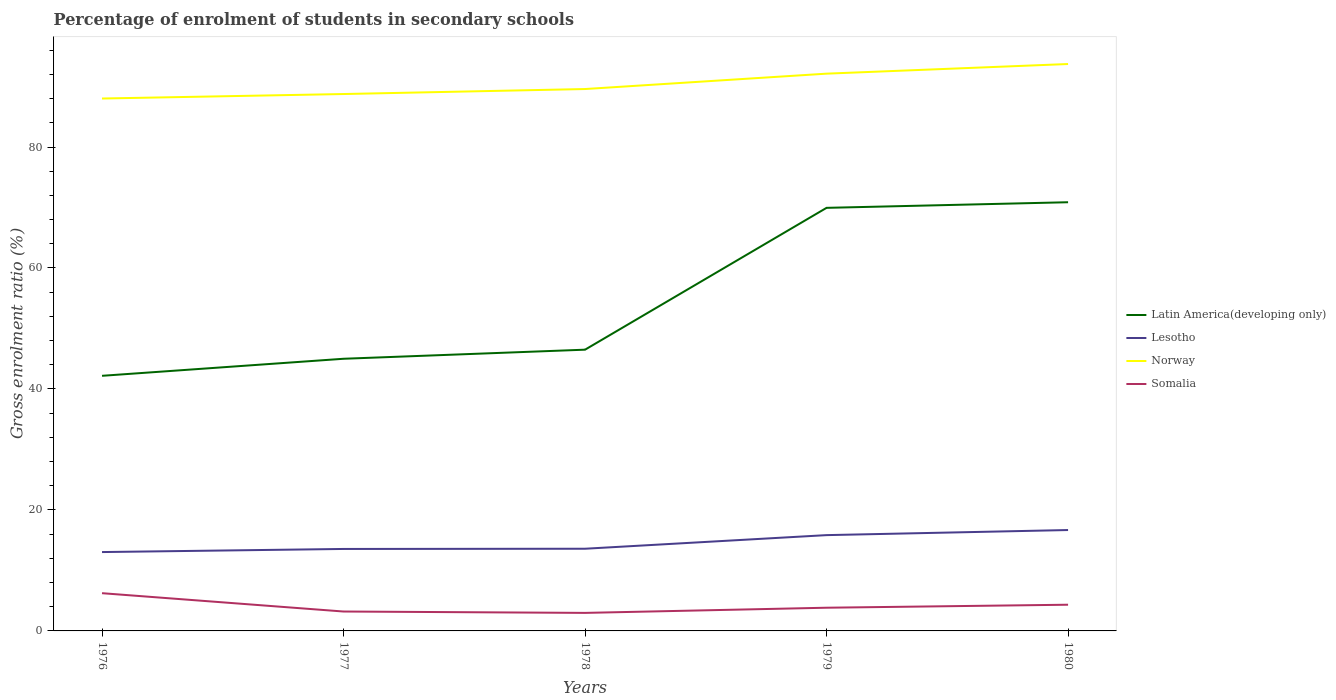Does the line corresponding to Somalia intersect with the line corresponding to Lesotho?
Offer a very short reply. No. Across all years, what is the maximum percentage of students enrolled in secondary schools in Norway?
Provide a succinct answer. 88.02. In which year was the percentage of students enrolled in secondary schools in Lesotho maximum?
Give a very brief answer. 1976. What is the total percentage of students enrolled in secondary schools in Lesotho in the graph?
Provide a succinct answer. -0.51. What is the difference between the highest and the second highest percentage of students enrolled in secondary schools in Somalia?
Your response must be concise. 3.26. What is the difference between the highest and the lowest percentage of students enrolled in secondary schools in Latin America(developing only)?
Offer a very short reply. 2. Are the values on the major ticks of Y-axis written in scientific E-notation?
Your answer should be very brief. No. Does the graph contain any zero values?
Keep it short and to the point. No. Does the graph contain grids?
Provide a short and direct response. No. What is the title of the graph?
Give a very brief answer. Percentage of enrolment of students in secondary schools. Does "Malta" appear as one of the legend labels in the graph?
Your answer should be compact. No. What is the label or title of the X-axis?
Provide a short and direct response. Years. What is the label or title of the Y-axis?
Your response must be concise. Gross enrolment ratio (%). What is the Gross enrolment ratio (%) in Latin America(developing only) in 1976?
Offer a very short reply. 42.18. What is the Gross enrolment ratio (%) in Lesotho in 1976?
Offer a very short reply. 13.04. What is the Gross enrolment ratio (%) of Norway in 1976?
Your response must be concise. 88.02. What is the Gross enrolment ratio (%) in Somalia in 1976?
Ensure brevity in your answer.  6.24. What is the Gross enrolment ratio (%) of Latin America(developing only) in 1977?
Keep it short and to the point. 44.99. What is the Gross enrolment ratio (%) of Lesotho in 1977?
Provide a succinct answer. 13.55. What is the Gross enrolment ratio (%) in Norway in 1977?
Keep it short and to the point. 88.76. What is the Gross enrolment ratio (%) of Somalia in 1977?
Make the answer very short. 3.21. What is the Gross enrolment ratio (%) of Latin America(developing only) in 1978?
Offer a very short reply. 46.5. What is the Gross enrolment ratio (%) of Lesotho in 1978?
Provide a succinct answer. 13.59. What is the Gross enrolment ratio (%) in Norway in 1978?
Your answer should be compact. 89.59. What is the Gross enrolment ratio (%) of Somalia in 1978?
Provide a short and direct response. 2.98. What is the Gross enrolment ratio (%) in Latin America(developing only) in 1979?
Make the answer very short. 69.94. What is the Gross enrolment ratio (%) of Lesotho in 1979?
Your answer should be compact. 15.84. What is the Gross enrolment ratio (%) in Norway in 1979?
Offer a very short reply. 92.13. What is the Gross enrolment ratio (%) in Somalia in 1979?
Make the answer very short. 3.84. What is the Gross enrolment ratio (%) of Latin America(developing only) in 1980?
Make the answer very short. 70.87. What is the Gross enrolment ratio (%) in Lesotho in 1980?
Your answer should be compact. 16.68. What is the Gross enrolment ratio (%) of Norway in 1980?
Keep it short and to the point. 93.72. What is the Gross enrolment ratio (%) in Somalia in 1980?
Your response must be concise. 4.33. Across all years, what is the maximum Gross enrolment ratio (%) in Latin America(developing only)?
Offer a terse response. 70.87. Across all years, what is the maximum Gross enrolment ratio (%) of Lesotho?
Your answer should be compact. 16.68. Across all years, what is the maximum Gross enrolment ratio (%) in Norway?
Offer a terse response. 93.72. Across all years, what is the maximum Gross enrolment ratio (%) in Somalia?
Offer a terse response. 6.24. Across all years, what is the minimum Gross enrolment ratio (%) of Latin America(developing only)?
Offer a very short reply. 42.18. Across all years, what is the minimum Gross enrolment ratio (%) in Lesotho?
Your answer should be very brief. 13.04. Across all years, what is the minimum Gross enrolment ratio (%) in Norway?
Your response must be concise. 88.02. Across all years, what is the minimum Gross enrolment ratio (%) in Somalia?
Offer a terse response. 2.98. What is the total Gross enrolment ratio (%) of Latin America(developing only) in the graph?
Your answer should be compact. 274.48. What is the total Gross enrolment ratio (%) in Lesotho in the graph?
Offer a very short reply. 72.69. What is the total Gross enrolment ratio (%) of Norway in the graph?
Keep it short and to the point. 452.22. What is the total Gross enrolment ratio (%) in Somalia in the graph?
Provide a short and direct response. 20.59. What is the difference between the Gross enrolment ratio (%) in Latin America(developing only) in 1976 and that in 1977?
Give a very brief answer. -2.82. What is the difference between the Gross enrolment ratio (%) of Lesotho in 1976 and that in 1977?
Your answer should be very brief. -0.51. What is the difference between the Gross enrolment ratio (%) of Norway in 1976 and that in 1977?
Your answer should be very brief. -0.74. What is the difference between the Gross enrolment ratio (%) in Somalia in 1976 and that in 1977?
Keep it short and to the point. 3.03. What is the difference between the Gross enrolment ratio (%) of Latin America(developing only) in 1976 and that in 1978?
Your answer should be very brief. -4.32. What is the difference between the Gross enrolment ratio (%) of Lesotho in 1976 and that in 1978?
Offer a terse response. -0.55. What is the difference between the Gross enrolment ratio (%) of Norway in 1976 and that in 1978?
Your answer should be very brief. -1.57. What is the difference between the Gross enrolment ratio (%) of Somalia in 1976 and that in 1978?
Offer a terse response. 3.26. What is the difference between the Gross enrolment ratio (%) in Latin America(developing only) in 1976 and that in 1979?
Offer a very short reply. -27.77. What is the difference between the Gross enrolment ratio (%) of Lesotho in 1976 and that in 1979?
Offer a very short reply. -2.8. What is the difference between the Gross enrolment ratio (%) in Norway in 1976 and that in 1979?
Keep it short and to the point. -4.11. What is the difference between the Gross enrolment ratio (%) in Somalia in 1976 and that in 1979?
Provide a succinct answer. 2.4. What is the difference between the Gross enrolment ratio (%) in Latin America(developing only) in 1976 and that in 1980?
Your response must be concise. -28.7. What is the difference between the Gross enrolment ratio (%) in Lesotho in 1976 and that in 1980?
Ensure brevity in your answer.  -3.64. What is the difference between the Gross enrolment ratio (%) in Norway in 1976 and that in 1980?
Offer a terse response. -5.7. What is the difference between the Gross enrolment ratio (%) in Somalia in 1976 and that in 1980?
Your answer should be compact. 1.91. What is the difference between the Gross enrolment ratio (%) of Latin America(developing only) in 1977 and that in 1978?
Offer a terse response. -1.5. What is the difference between the Gross enrolment ratio (%) of Lesotho in 1977 and that in 1978?
Your answer should be compact. -0.04. What is the difference between the Gross enrolment ratio (%) in Norway in 1977 and that in 1978?
Your response must be concise. -0.83. What is the difference between the Gross enrolment ratio (%) of Somalia in 1977 and that in 1978?
Give a very brief answer. 0.23. What is the difference between the Gross enrolment ratio (%) of Latin America(developing only) in 1977 and that in 1979?
Provide a short and direct response. -24.95. What is the difference between the Gross enrolment ratio (%) of Lesotho in 1977 and that in 1979?
Provide a succinct answer. -2.29. What is the difference between the Gross enrolment ratio (%) of Norway in 1977 and that in 1979?
Your answer should be very brief. -3.37. What is the difference between the Gross enrolment ratio (%) of Somalia in 1977 and that in 1979?
Your answer should be compact. -0.63. What is the difference between the Gross enrolment ratio (%) of Latin America(developing only) in 1977 and that in 1980?
Provide a succinct answer. -25.88. What is the difference between the Gross enrolment ratio (%) of Lesotho in 1977 and that in 1980?
Keep it short and to the point. -3.13. What is the difference between the Gross enrolment ratio (%) of Norway in 1977 and that in 1980?
Give a very brief answer. -4.96. What is the difference between the Gross enrolment ratio (%) in Somalia in 1977 and that in 1980?
Keep it short and to the point. -1.12. What is the difference between the Gross enrolment ratio (%) of Latin America(developing only) in 1978 and that in 1979?
Ensure brevity in your answer.  -23.45. What is the difference between the Gross enrolment ratio (%) in Lesotho in 1978 and that in 1979?
Your response must be concise. -2.25. What is the difference between the Gross enrolment ratio (%) of Norway in 1978 and that in 1979?
Provide a short and direct response. -2.54. What is the difference between the Gross enrolment ratio (%) in Somalia in 1978 and that in 1979?
Make the answer very short. -0.85. What is the difference between the Gross enrolment ratio (%) of Latin America(developing only) in 1978 and that in 1980?
Give a very brief answer. -24.38. What is the difference between the Gross enrolment ratio (%) of Lesotho in 1978 and that in 1980?
Provide a succinct answer. -3.09. What is the difference between the Gross enrolment ratio (%) in Norway in 1978 and that in 1980?
Provide a succinct answer. -4.14. What is the difference between the Gross enrolment ratio (%) in Somalia in 1978 and that in 1980?
Offer a very short reply. -1.35. What is the difference between the Gross enrolment ratio (%) of Latin America(developing only) in 1979 and that in 1980?
Offer a terse response. -0.93. What is the difference between the Gross enrolment ratio (%) in Lesotho in 1979 and that in 1980?
Offer a terse response. -0.84. What is the difference between the Gross enrolment ratio (%) in Norway in 1979 and that in 1980?
Provide a succinct answer. -1.59. What is the difference between the Gross enrolment ratio (%) of Somalia in 1979 and that in 1980?
Your answer should be compact. -0.5. What is the difference between the Gross enrolment ratio (%) of Latin America(developing only) in 1976 and the Gross enrolment ratio (%) of Lesotho in 1977?
Your response must be concise. 28.63. What is the difference between the Gross enrolment ratio (%) of Latin America(developing only) in 1976 and the Gross enrolment ratio (%) of Norway in 1977?
Offer a terse response. -46.59. What is the difference between the Gross enrolment ratio (%) of Latin America(developing only) in 1976 and the Gross enrolment ratio (%) of Somalia in 1977?
Make the answer very short. 38.97. What is the difference between the Gross enrolment ratio (%) in Lesotho in 1976 and the Gross enrolment ratio (%) in Norway in 1977?
Your response must be concise. -75.72. What is the difference between the Gross enrolment ratio (%) of Lesotho in 1976 and the Gross enrolment ratio (%) of Somalia in 1977?
Give a very brief answer. 9.83. What is the difference between the Gross enrolment ratio (%) of Norway in 1976 and the Gross enrolment ratio (%) of Somalia in 1977?
Ensure brevity in your answer.  84.81. What is the difference between the Gross enrolment ratio (%) of Latin America(developing only) in 1976 and the Gross enrolment ratio (%) of Lesotho in 1978?
Make the answer very short. 28.59. What is the difference between the Gross enrolment ratio (%) in Latin America(developing only) in 1976 and the Gross enrolment ratio (%) in Norway in 1978?
Your answer should be very brief. -47.41. What is the difference between the Gross enrolment ratio (%) in Latin America(developing only) in 1976 and the Gross enrolment ratio (%) in Somalia in 1978?
Your answer should be compact. 39.19. What is the difference between the Gross enrolment ratio (%) of Lesotho in 1976 and the Gross enrolment ratio (%) of Norway in 1978?
Provide a succinct answer. -76.55. What is the difference between the Gross enrolment ratio (%) of Lesotho in 1976 and the Gross enrolment ratio (%) of Somalia in 1978?
Provide a succinct answer. 10.06. What is the difference between the Gross enrolment ratio (%) in Norway in 1976 and the Gross enrolment ratio (%) in Somalia in 1978?
Make the answer very short. 85.04. What is the difference between the Gross enrolment ratio (%) in Latin America(developing only) in 1976 and the Gross enrolment ratio (%) in Lesotho in 1979?
Make the answer very short. 26.34. What is the difference between the Gross enrolment ratio (%) in Latin America(developing only) in 1976 and the Gross enrolment ratio (%) in Norway in 1979?
Provide a short and direct response. -49.95. What is the difference between the Gross enrolment ratio (%) of Latin America(developing only) in 1976 and the Gross enrolment ratio (%) of Somalia in 1979?
Offer a very short reply. 38.34. What is the difference between the Gross enrolment ratio (%) in Lesotho in 1976 and the Gross enrolment ratio (%) in Norway in 1979?
Make the answer very short. -79.09. What is the difference between the Gross enrolment ratio (%) of Lesotho in 1976 and the Gross enrolment ratio (%) of Somalia in 1979?
Your response must be concise. 9.2. What is the difference between the Gross enrolment ratio (%) of Norway in 1976 and the Gross enrolment ratio (%) of Somalia in 1979?
Provide a short and direct response. 84.18. What is the difference between the Gross enrolment ratio (%) of Latin America(developing only) in 1976 and the Gross enrolment ratio (%) of Lesotho in 1980?
Keep it short and to the point. 25.5. What is the difference between the Gross enrolment ratio (%) of Latin America(developing only) in 1976 and the Gross enrolment ratio (%) of Norway in 1980?
Provide a succinct answer. -51.55. What is the difference between the Gross enrolment ratio (%) in Latin America(developing only) in 1976 and the Gross enrolment ratio (%) in Somalia in 1980?
Make the answer very short. 37.84. What is the difference between the Gross enrolment ratio (%) of Lesotho in 1976 and the Gross enrolment ratio (%) of Norway in 1980?
Give a very brief answer. -80.68. What is the difference between the Gross enrolment ratio (%) in Lesotho in 1976 and the Gross enrolment ratio (%) in Somalia in 1980?
Keep it short and to the point. 8.71. What is the difference between the Gross enrolment ratio (%) in Norway in 1976 and the Gross enrolment ratio (%) in Somalia in 1980?
Provide a short and direct response. 83.69. What is the difference between the Gross enrolment ratio (%) in Latin America(developing only) in 1977 and the Gross enrolment ratio (%) in Lesotho in 1978?
Make the answer very short. 31.41. What is the difference between the Gross enrolment ratio (%) in Latin America(developing only) in 1977 and the Gross enrolment ratio (%) in Norway in 1978?
Offer a very short reply. -44.59. What is the difference between the Gross enrolment ratio (%) in Latin America(developing only) in 1977 and the Gross enrolment ratio (%) in Somalia in 1978?
Make the answer very short. 42.01. What is the difference between the Gross enrolment ratio (%) of Lesotho in 1977 and the Gross enrolment ratio (%) of Norway in 1978?
Make the answer very short. -76.04. What is the difference between the Gross enrolment ratio (%) of Lesotho in 1977 and the Gross enrolment ratio (%) of Somalia in 1978?
Provide a succinct answer. 10.57. What is the difference between the Gross enrolment ratio (%) in Norway in 1977 and the Gross enrolment ratio (%) in Somalia in 1978?
Make the answer very short. 85.78. What is the difference between the Gross enrolment ratio (%) in Latin America(developing only) in 1977 and the Gross enrolment ratio (%) in Lesotho in 1979?
Give a very brief answer. 29.16. What is the difference between the Gross enrolment ratio (%) of Latin America(developing only) in 1977 and the Gross enrolment ratio (%) of Norway in 1979?
Offer a terse response. -47.14. What is the difference between the Gross enrolment ratio (%) of Latin America(developing only) in 1977 and the Gross enrolment ratio (%) of Somalia in 1979?
Your answer should be compact. 41.16. What is the difference between the Gross enrolment ratio (%) in Lesotho in 1977 and the Gross enrolment ratio (%) in Norway in 1979?
Give a very brief answer. -78.58. What is the difference between the Gross enrolment ratio (%) in Lesotho in 1977 and the Gross enrolment ratio (%) in Somalia in 1979?
Offer a terse response. 9.71. What is the difference between the Gross enrolment ratio (%) in Norway in 1977 and the Gross enrolment ratio (%) in Somalia in 1979?
Make the answer very short. 84.93. What is the difference between the Gross enrolment ratio (%) of Latin America(developing only) in 1977 and the Gross enrolment ratio (%) of Lesotho in 1980?
Your answer should be very brief. 28.31. What is the difference between the Gross enrolment ratio (%) in Latin America(developing only) in 1977 and the Gross enrolment ratio (%) in Norway in 1980?
Offer a very short reply. -48.73. What is the difference between the Gross enrolment ratio (%) in Latin America(developing only) in 1977 and the Gross enrolment ratio (%) in Somalia in 1980?
Ensure brevity in your answer.  40.66. What is the difference between the Gross enrolment ratio (%) of Lesotho in 1977 and the Gross enrolment ratio (%) of Norway in 1980?
Provide a short and direct response. -80.17. What is the difference between the Gross enrolment ratio (%) in Lesotho in 1977 and the Gross enrolment ratio (%) in Somalia in 1980?
Ensure brevity in your answer.  9.22. What is the difference between the Gross enrolment ratio (%) of Norway in 1977 and the Gross enrolment ratio (%) of Somalia in 1980?
Provide a succinct answer. 84.43. What is the difference between the Gross enrolment ratio (%) in Latin America(developing only) in 1978 and the Gross enrolment ratio (%) in Lesotho in 1979?
Give a very brief answer. 30.66. What is the difference between the Gross enrolment ratio (%) of Latin America(developing only) in 1978 and the Gross enrolment ratio (%) of Norway in 1979?
Offer a very short reply. -45.63. What is the difference between the Gross enrolment ratio (%) of Latin America(developing only) in 1978 and the Gross enrolment ratio (%) of Somalia in 1979?
Offer a very short reply. 42.66. What is the difference between the Gross enrolment ratio (%) of Lesotho in 1978 and the Gross enrolment ratio (%) of Norway in 1979?
Provide a succinct answer. -78.54. What is the difference between the Gross enrolment ratio (%) of Lesotho in 1978 and the Gross enrolment ratio (%) of Somalia in 1979?
Provide a short and direct response. 9.75. What is the difference between the Gross enrolment ratio (%) of Norway in 1978 and the Gross enrolment ratio (%) of Somalia in 1979?
Ensure brevity in your answer.  85.75. What is the difference between the Gross enrolment ratio (%) of Latin America(developing only) in 1978 and the Gross enrolment ratio (%) of Lesotho in 1980?
Make the answer very short. 29.82. What is the difference between the Gross enrolment ratio (%) in Latin America(developing only) in 1978 and the Gross enrolment ratio (%) in Norway in 1980?
Ensure brevity in your answer.  -47.23. What is the difference between the Gross enrolment ratio (%) of Latin America(developing only) in 1978 and the Gross enrolment ratio (%) of Somalia in 1980?
Your answer should be compact. 42.16. What is the difference between the Gross enrolment ratio (%) of Lesotho in 1978 and the Gross enrolment ratio (%) of Norway in 1980?
Your answer should be very brief. -80.13. What is the difference between the Gross enrolment ratio (%) in Lesotho in 1978 and the Gross enrolment ratio (%) in Somalia in 1980?
Make the answer very short. 9.26. What is the difference between the Gross enrolment ratio (%) of Norway in 1978 and the Gross enrolment ratio (%) of Somalia in 1980?
Your answer should be very brief. 85.26. What is the difference between the Gross enrolment ratio (%) in Latin America(developing only) in 1979 and the Gross enrolment ratio (%) in Lesotho in 1980?
Provide a succinct answer. 53.27. What is the difference between the Gross enrolment ratio (%) in Latin America(developing only) in 1979 and the Gross enrolment ratio (%) in Norway in 1980?
Your answer should be compact. -23.78. What is the difference between the Gross enrolment ratio (%) in Latin America(developing only) in 1979 and the Gross enrolment ratio (%) in Somalia in 1980?
Give a very brief answer. 65.61. What is the difference between the Gross enrolment ratio (%) in Lesotho in 1979 and the Gross enrolment ratio (%) in Norway in 1980?
Offer a very short reply. -77.88. What is the difference between the Gross enrolment ratio (%) of Lesotho in 1979 and the Gross enrolment ratio (%) of Somalia in 1980?
Your answer should be compact. 11.51. What is the difference between the Gross enrolment ratio (%) of Norway in 1979 and the Gross enrolment ratio (%) of Somalia in 1980?
Keep it short and to the point. 87.8. What is the average Gross enrolment ratio (%) in Latin America(developing only) per year?
Offer a very short reply. 54.9. What is the average Gross enrolment ratio (%) of Lesotho per year?
Your answer should be very brief. 14.54. What is the average Gross enrolment ratio (%) of Norway per year?
Keep it short and to the point. 90.44. What is the average Gross enrolment ratio (%) in Somalia per year?
Give a very brief answer. 4.12. In the year 1976, what is the difference between the Gross enrolment ratio (%) in Latin America(developing only) and Gross enrolment ratio (%) in Lesotho?
Provide a short and direct response. 29.14. In the year 1976, what is the difference between the Gross enrolment ratio (%) of Latin America(developing only) and Gross enrolment ratio (%) of Norway?
Make the answer very short. -45.84. In the year 1976, what is the difference between the Gross enrolment ratio (%) of Latin America(developing only) and Gross enrolment ratio (%) of Somalia?
Your answer should be compact. 35.94. In the year 1976, what is the difference between the Gross enrolment ratio (%) in Lesotho and Gross enrolment ratio (%) in Norway?
Your answer should be compact. -74.98. In the year 1976, what is the difference between the Gross enrolment ratio (%) of Lesotho and Gross enrolment ratio (%) of Somalia?
Give a very brief answer. 6.8. In the year 1976, what is the difference between the Gross enrolment ratio (%) in Norway and Gross enrolment ratio (%) in Somalia?
Offer a very short reply. 81.78. In the year 1977, what is the difference between the Gross enrolment ratio (%) in Latin America(developing only) and Gross enrolment ratio (%) in Lesotho?
Keep it short and to the point. 31.44. In the year 1977, what is the difference between the Gross enrolment ratio (%) in Latin America(developing only) and Gross enrolment ratio (%) in Norway?
Your response must be concise. -43.77. In the year 1977, what is the difference between the Gross enrolment ratio (%) of Latin America(developing only) and Gross enrolment ratio (%) of Somalia?
Provide a succinct answer. 41.79. In the year 1977, what is the difference between the Gross enrolment ratio (%) in Lesotho and Gross enrolment ratio (%) in Norway?
Your answer should be very brief. -75.21. In the year 1977, what is the difference between the Gross enrolment ratio (%) in Lesotho and Gross enrolment ratio (%) in Somalia?
Your answer should be compact. 10.34. In the year 1977, what is the difference between the Gross enrolment ratio (%) of Norway and Gross enrolment ratio (%) of Somalia?
Give a very brief answer. 85.55. In the year 1978, what is the difference between the Gross enrolment ratio (%) in Latin America(developing only) and Gross enrolment ratio (%) in Lesotho?
Your response must be concise. 32.91. In the year 1978, what is the difference between the Gross enrolment ratio (%) in Latin America(developing only) and Gross enrolment ratio (%) in Norway?
Offer a very short reply. -43.09. In the year 1978, what is the difference between the Gross enrolment ratio (%) of Latin America(developing only) and Gross enrolment ratio (%) of Somalia?
Keep it short and to the point. 43.51. In the year 1978, what is the difference between the Gross enrolment ratio (%) in Lesotho and Gross enrolment ratio (%) in Norway?
Ensure brevity in your answer.  -76. In the year 1978, what is the difference between the Gross enrolment ratio (%) in Lesotho and Gross enrolment ratio (%) in Somalia?
Provide a succinct answer. 10.61. In the year 1978, what is the difference between the Gross enrolment ratio (%) of Norway and Gross enrolment ratio (%) of Somalia?
Keep it short and to the point. 86.61. In the year 1979, what is the difference between the Gross enrolment ratio (%) of Latin America(developing only) and Gross enrolment ratio (%) of Lesotho?
Your answer should be compact. 54.11. In the year 1979, what is the difference between the Gross enrolment ratio (%) of Latin America(developing only) and Gross enrolment ratio (%) of Norway?
Your answer should be compact. -22.18. In the year 1979, what is the difference between the Gross enrolment ratio (%) in Latin America(developing only) and Gross enrolment ratio (%) in Somalia?
Your response must be concise. 66.11. In the year 1979, what is the difference between the Gross enrolment ratio (%) in Lesotho and Gross enrolment ratio (%) in Norway?
Offer a terse response. -76.29. In the year 1979, what is the difference between the Gross enrolment ratio (%) of Lesotho and Gross enrolment ratio (%) of Somalia?
Make the answer very short. 12. In the year 1979, what is the difference between the Gross enrolment ratio (%) in Norway and Gross enrolment ratio (%) in Somalia?
Your answer should be very brief. 88.29. In the year 1980, what is the difference between the Gross enrolment ratio (%) of Latin America(developing only) and Gross enrolment ratio (%) of Lesotho?
Offer a very short reply. 54.19. In the year 1980, what is the difference between the Gross enrolment ratio (%) of Latin America(developing only) and Gross enrolment ratio (%) of Norway?
Provide a short and direct response. -22.85. In the year 1980, what is the difference between the Gross enrolment ratio (%) in Latin America(developing only) and Gross enrolment ratio (%) in Somalia?
Your answer should be compact. 66.54. In the year 1980, what is the difference between the Gross enrolment ratio (%) in Lesotho and Gross enrolment ratio (%) in Norway?
Ensure brevity in your answer.  -77.04. In the year 1980, what is the difference between the Gross enrolment ratio (%) of Lesotho and Gross enrolment ratio (%) of Somalia?
Make the answer very short. 12.35. In the year 1980, what is the difference between the Gross enrolment ratio (%) in Norway and Gross enrolment ratio (%) in Somalia?
Offer a very short reply. 89.39. What is the ratio of the Gross enrolment ratio (%) of Latin America(developing only) in 1976 to that in 1977?
Your response must be concise. 0.94. What is the ratio of the Gross enrolment ratio (%) of Lesotho in 1976 to that in 1977?
Ensure brevity in your answer.  0.96. What is the ratio of the Gross enrolment ratio (%) in Somalia in 1976 to that in 1977?
Your answer should be very brief. 1.95. What is the ratio of the Gross enrolment ratio (%) in Latin America(developing only) in 1976 to that in 1978?
Keep it short and to the point. 0.91. What is the ratio of the Gross enrolment ratio (%) of Lesotho in 1976 to that in 1978?
Provide a succinct answer. 0.96. What is the ratio of the Gross enrolment ratio (%) of Norway in 1976 to that in 1978?
Make the answer very short. 0.98. What is the ratio of the Gross enrolment ratio (%) of Somalia in 1976 to that in 1978?
Offer a very short reply. 2.09. What is the ratio of the Gross enrolment ratio (%) of Latin America(developing only) in 1976 to that in 1979?
Make the answer very short. 0.6. What is the ratio of the Gross enrolment ratio (%) in Lesotho in 1976 to that in 1979?
Your response must be concise. 0.82. What is the ratio of the Gross enrolment ratio (%) of Norway in 1976 to that in 1979?
Offer a terse response. 0.96. What is the ratio of the Gross enrolment ratio (%) in Somalia in 1976 to that in 1979?
Your answer should be very brief. 1.63. What is the ratio of the Gross enrolment ratio (%) in Latin America(developing only) in 1976 to that in 1980?
Give a very brief answer. 0.6. What is the ratio of the Gross enrolment ratio (%) of Lesotho in 1976 to that in 1980?
Offer a terse response. 0.78. What is the ratio of the Gross enrolment ratio (%) of Norway in 1976 to that in 1980?
Your response must be concise. 0.94. What is the ratio of the Gross enrolment ratio (%) of Somalia in 1976 to that in 1980?
Your response must be concise. 1.44. What is the ratio of the Gross enrolment ratio (%) of Latin America(developing only) in 1977 to that in 1978?
Ensure brevity in your answer.  0.97. What is the ratio of the Gross enrolment ratio (%) in Somalia in 1977 to that in 1978?
Your answer should be compact. 1.08. What is the ratio of the Gross enrolment ratio (%) of Latin America(developing only) in 1977 to that in 1979?
Ensure brevity in your answer.  0.64. What is the ratio of the Gross enrolment ratio (%) of Lesotho in 1977 to that in 1979?
Provide a succinct answer. 0.86. What is the ratio of the Gross enrolment ratio (%) of Norway in 1977 to that in 1979?
Provide a succinct answer. 0.96. What is the ratio of the Gross enrolment ratio (%) of Somalia in 1977 to that in 1979?
Offer a very short reply. 0.84. What is the ratio of the Gross enrolment ratio (%) of Latin America(developing only) in 1977 to that in 1980?
Provide a short and direct response. 0.63. What is the ratio of the Gross enrolment ratio (%) in Lesotho in 1977 to that in 1980?
Offer a terse response. 0.81. What is the ratio of the Gross enrolment ratio (%) of Norway in 1977 to that in 1980?
Offer a terse response. 0.95. What is the ratio of the Gross enrolment ratio (%) in Somalia in 1977 to that in 1980?
Ensure brevity in your answer.  0.74. What is the ratio of the Gross enrolment ratio (%) of Latin America(developing only) in 1978 to that in 1979?
Give a very brief answer. 0.66. What is the ratio of the Gross enrolment ratio (%) in Lesotho in 1978 to that in 1979?
Your answer should be compact. 0.86. What is the ratio of the Gross enrolment ratio (%) of Norway in 1978 to that in 1979?
Give a very brief answer. 0.97. What is the ratio of the Gross enrolment ratio (%) of Somalia in 1978 to that in 1979?
Ensure brevity in your answer.  0.78. What is the ratio of the Gross enrolment ratio (%) in Latin America(developing only) in 1978 to that in 1980?
Provide a short and direct response. 0.66. What is the ratio of the Gross enrolment ratio (%) of Lesotho in 1978 to that in 1980?
Provide a succinct answer. 0.81. What is the ratio of the Gross enrolment ratio (%) of Norway in 1978 to that in 1980?
Offer a terse response. 0.96. What is the ratio of the Gross enrolment ratio (%) of Somalia in 1978 to that in 1980?
Provide a succinct answer. 0.69. What is the ratio of the Gross enrolment ratio (%) in Latin America(developing only) in 1979 to that in 1980?
Your answer should be compact. 0.99. What is the ratio of the Gross enrolment ratio (%) of Lesotho in 1979 to that in 1980?
Keep it short and to the point. 0.95. What is the ratio of the Gross enrolment ratio (%) of Somalia in 1979 to that in 1980?
Your answer should be compact. 0.89. What is the difference between the highest and the second highest Gross enrolment ratio (%) of Latin America(developing only)?
Your answer should be very brief. 0.93. What is the difference between the highest and the second highest Gross enrolment ratio (%) of Lesotho?
Offer a terse response. 0.84. What is the difference between the highest and the second highest Gross enrolment ratio (%) in Norway?
Your answer should be very brief. 1.59. What is the difference between the highest and the second highest Gross enrolment ratio (%) in Somalia?
Offer a very short reply. 1.91. What is the difference between the highest and the lowest Gross enrolment ratio (%) in Latin America(developing only)?
Ensure brevity in your answer.  28.7. What is the difference between the highest and the lowest Gross enrolment ratio (%) of Lesotho?
Give a very brief answer. 3.64. What is the difference between the highest and the lowest Gross enrolment ratio (%) in Norway?
Your answer should be very brief. 5.7. What is the difference between the highest and the lowest Gross enrolment ratio (%) of Somalia?
Ensure brevity in your answer.  3.26. 